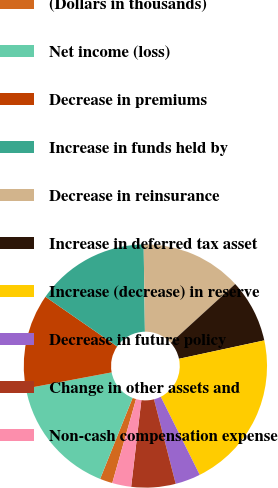<chart> <loc_0><loc_0><loc_500><loc_500><pie_chart><fcel>(Dollars in thousands)<fcel>Net income (loss)<fcel>Decrease in premiums<fcel>Increase in funds held by<fcel>Decrease in reinsurance<fcel>Increase in deferred tax asset<fcel>Increase (decrease) in reserve<fcel>Decrease in future policy<fcel>Change in other assets and<fcel>Non-cash compensation expense<nl><fcel>1.68%<fcel>15.97%<fcel>12.6%<fcel>15.13%<fcel>13.45%<fcel>8.4%<fcel>21.01%<fcel>3.36%<fcel>5.88%<fcel>2.52%<nl></chart> 